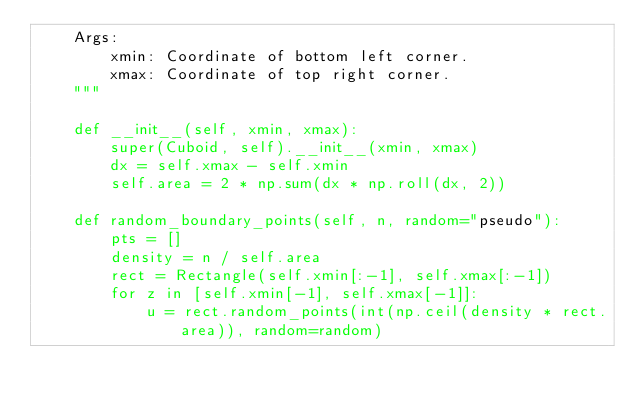Convert code to text. <code><loc_0><loc_0><loc_500><loc_500><_Python_>    Args:
        xmin: Coordinate of bottom left corner.
        xmax: Coordinate of top right corner.
    """

    def __init__(self, xmin, xmax):
        super(Cuboid, self).__init__(xmin, xmax)
        dx = self.xmax - self.xmin
        self.area = 2 * np.sum(dx * np.roll(dx, 2))

    def random_boundary_points(self, n, random="pseudo"):
        pts = []
        density = n / self.area
        rect = Rectangle(self.xmin[:-1], self.xmax[:-1])
        for z in [self.xmin[-1], self.xmax[-1]]:
            u = rect.random_points(int(np.ceil(density * rect.area)), random=random)</code> 